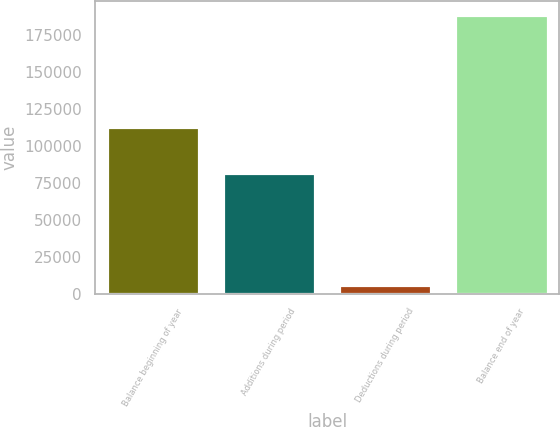Convert chart. <chart><loc_0><loc_0><loc_500><loc_500><bar_chart><fcel>Balance beginning of year<fcel>Additions during period<fcel>Deductions during period<fcel>Balance end of year<nl><fcel>112479<fcel>81318<fcel>5698<fcel>188099<nl></chart> 